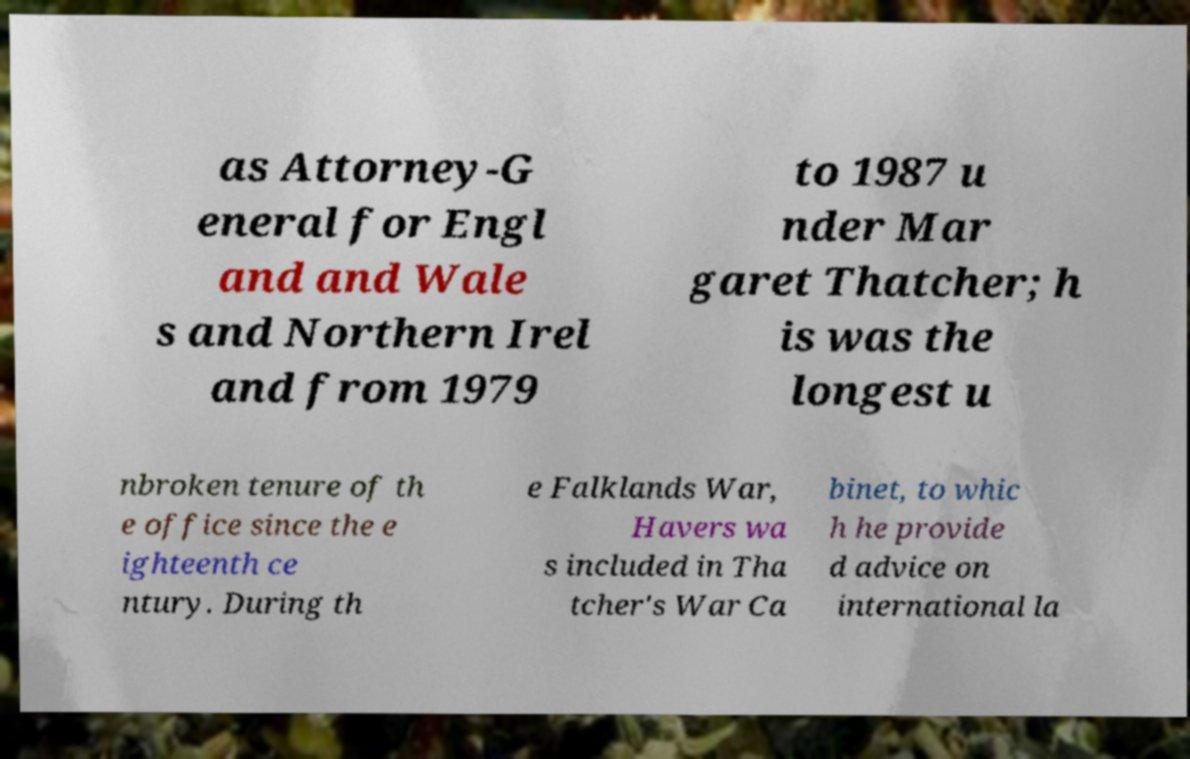Could you assist in decoding the text presented in this image and type it out clearly? as Attorney-G eneral for Engl and and Wale s and Northern Irel and from 1979 to 1987 u nder Mar garet Thatcher; h is was the longest u nbroken tenure of th e office since the e ighteenth ce ntury. During th e Falklands War, Havers wa s included in Tha tcher's War Ca binet, to whic h he provide d advice on international la 